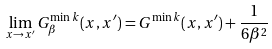<formula> <loc_0><loc_0><loc_500><loc_500>\lim _ { x \to x ^ { \prime } } G ^ { \min k } _ { \beta } ( x , x ^ { \prime } ) = G ^ { \min k } ( x , x ^ { \prime } ) + \frac { 1 } { 6 \beta ^ { 2 } }</formula> 